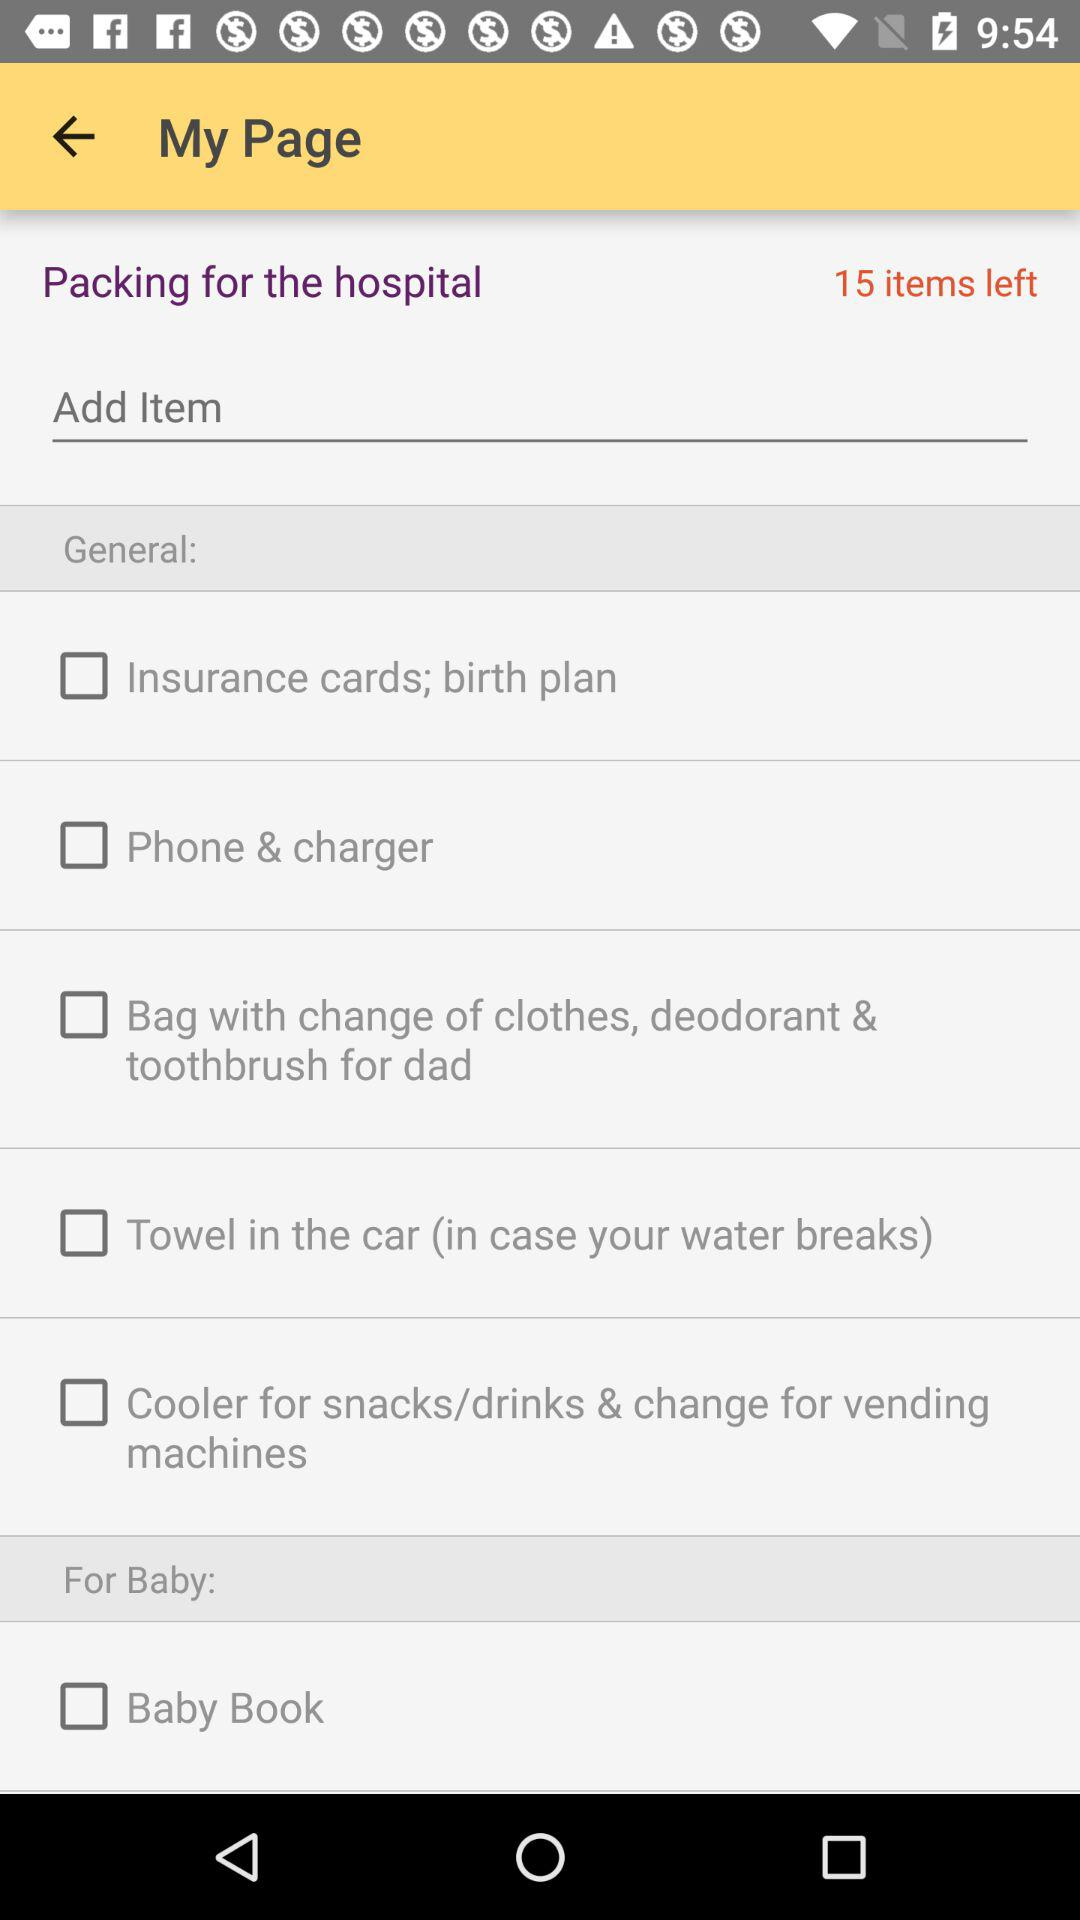What is the status of the "Phone & charger"? The status of the "Phone & charger" is "off". 